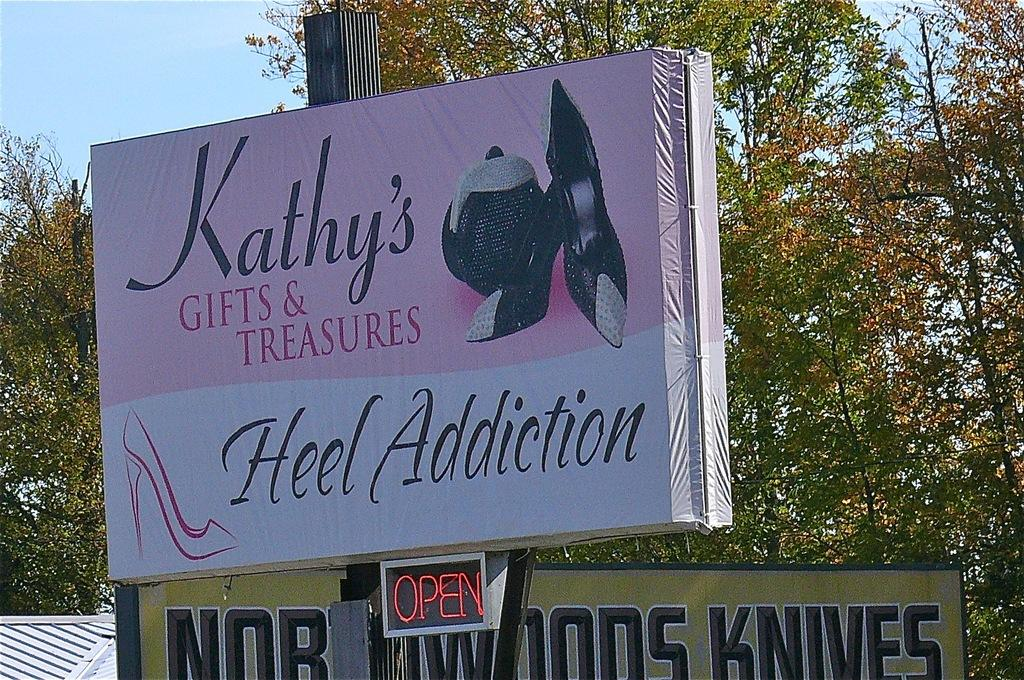<image>
Relay a brief, clear account of the picture shown. A sign for Kathy's gifts and treasures on the side of the road 